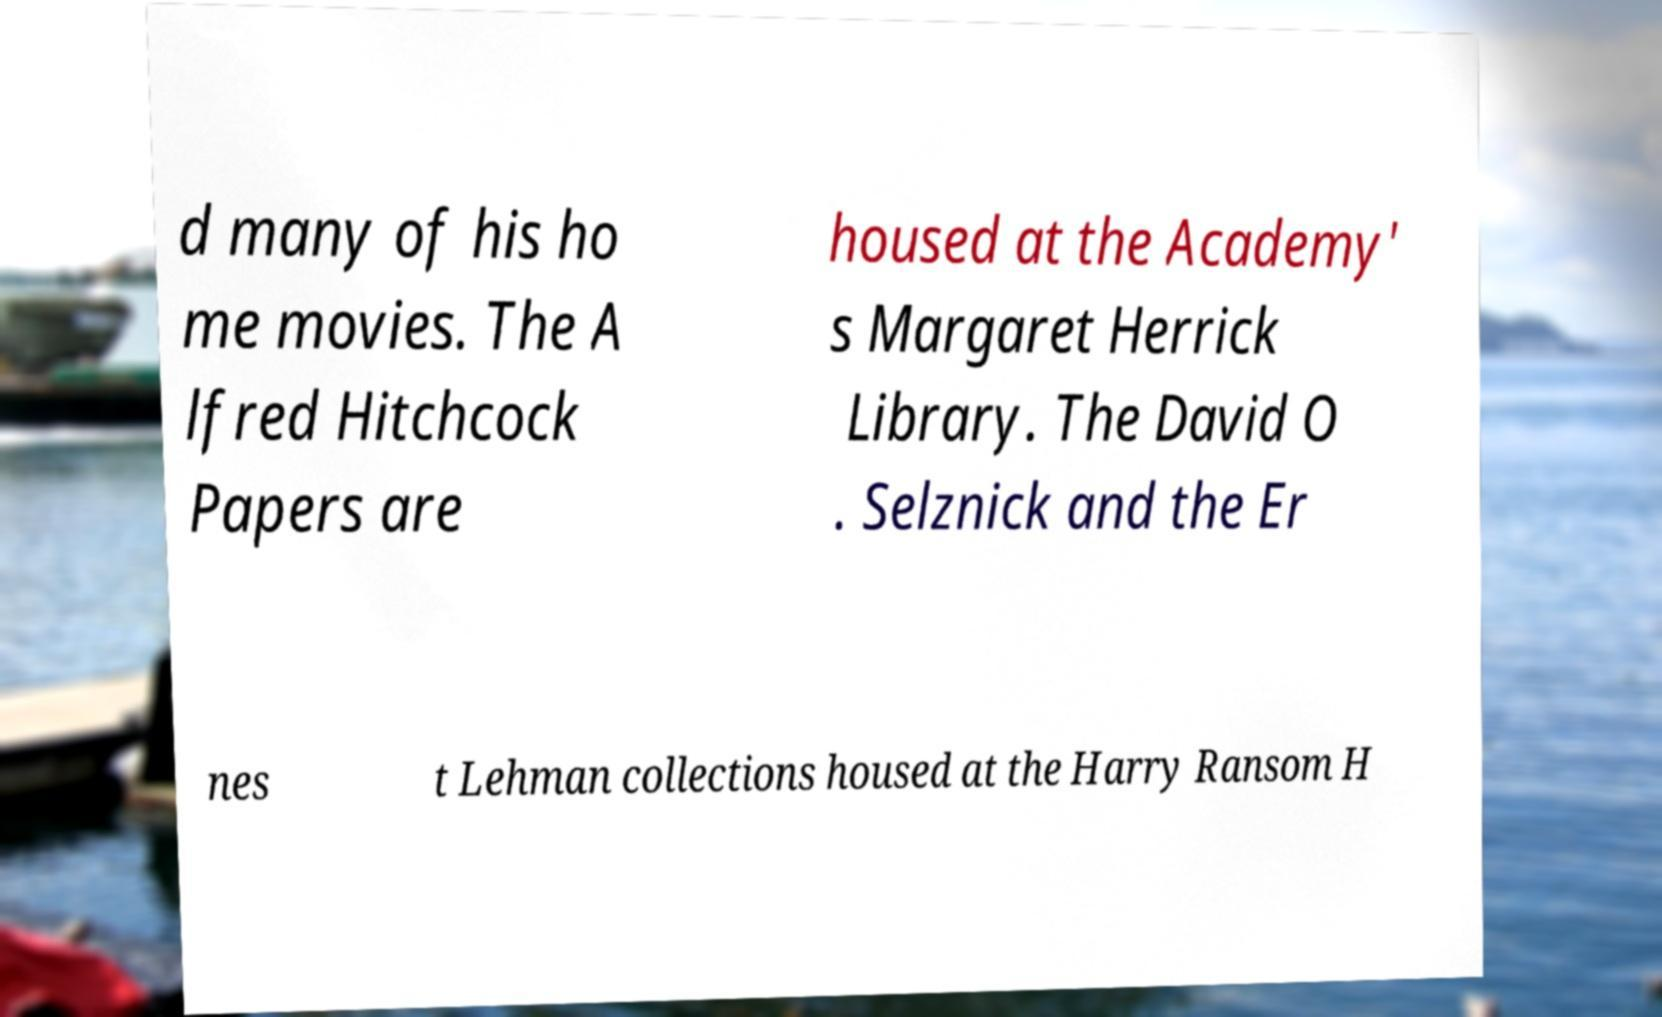Please read and relay the text visible in this image. What does it say? d many of his ho me movies. The A lfred Hitchcock Papers are housed at the Academy' s Margaret Herrick Library. The David O . Selznick and the Er nes t Lehman collections housed at the Harry Ransom H 